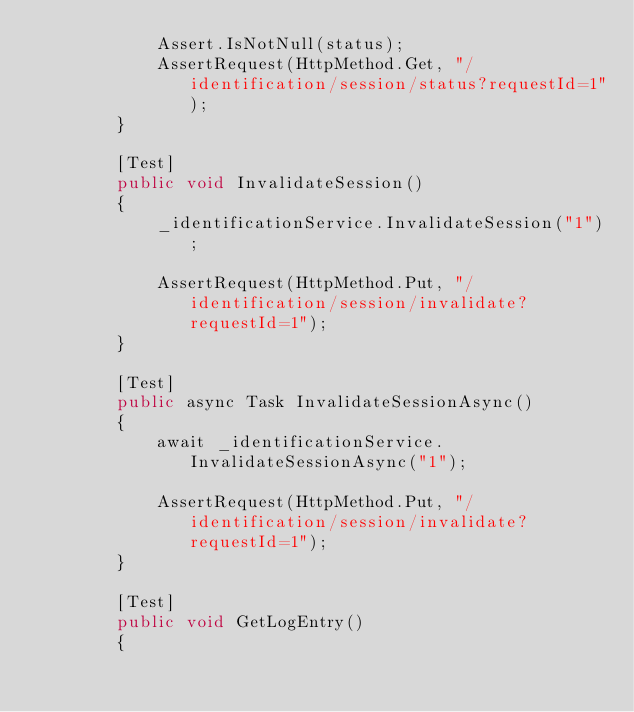<code> <loc_0><loc_0><loc_500><loc_500><_C#_>            Assert.IsNotNull(status);
            AssertRequest(HttpMethod.Get, "/identification/session/status?requestId=1");
        }
        
        [Test]
        public void InvalidateSession()
        {
            _identificationService.InvalidateSession("1");

            AssertRequest(HttpMethod.Put, "/identification/session/invalidate?requestId=1");
        }

        [Test]
        public async Task InvalidateSessionAsync()
        {
            await _identificationService.InvalidateSessionAsync("1");

            AssertRequest(HttpMethod.Put, "/identification/session/invalidate?requestId=1");
        }
        
        [Test]
        public void GetLogEntry()
        {</code> 